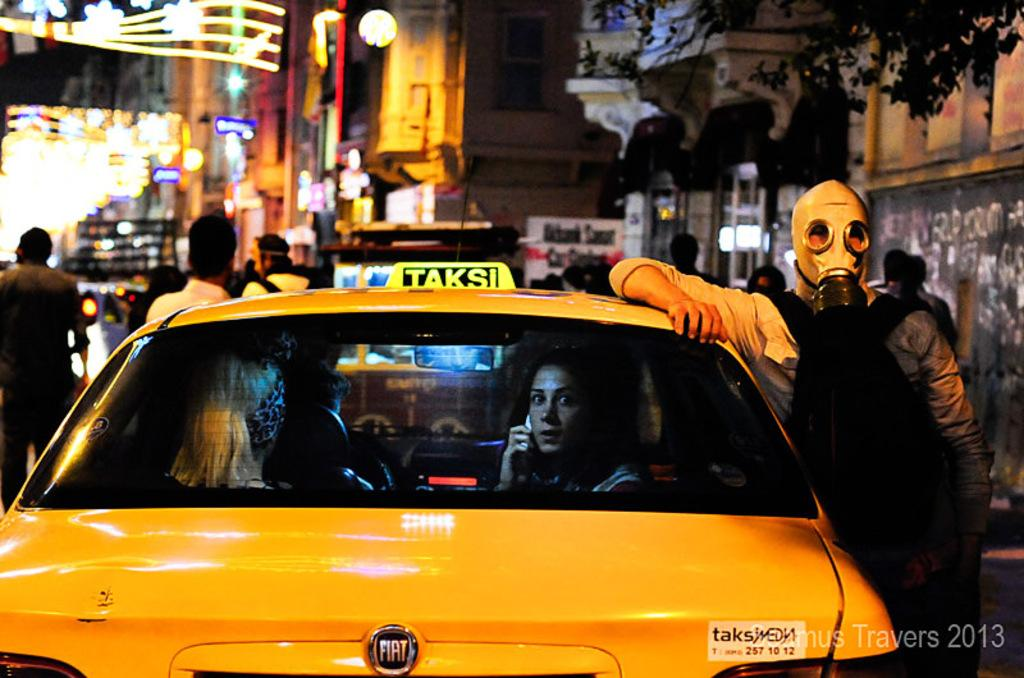<image>
Offer a succinct explanation of the picture presented. A man in a gas mask is leaning on a yellow car that says Taksi on top. 